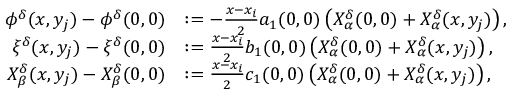<formula> <loc_0><loc_0><loc_500><loc_500>\begin{array} { r l } { \phi ^ { \delta } ( x , y _ { j } ) - \phi ^ { \delta } ( 0 , 0 ) } & { \colon = - \frac { x - x _ { i } } { 2 } a _ { 1 } ( 0 , 0 ) \left ( X _ { \alpha } ^ { \delta } ( 0 , 0 ) + X _ { \alpha } ^ { \delta } ( x , y _ { j } ) \right ) , } \\ { \xi ^ { \delta } ( x , y _ { j } ) - \xi ^ { \delta } ( 0 , 0 ) } & { \colon = \frac { x - x _ { i } } { 2 } b _ { 1 } ( 0 , 0 ) \left ( X _ { \alpha } ^ { \delta } ( 0 , 0 ) + X _ { \alpha } ^ { \delta } ( x , y _ { j } ) \right ) , } \\ { X _ { \beta } ^ { \delta } ( x , y _ { j } ) - X _ { \beta } ^ { \delta } ( 0 , 0 ) } & { \colon = \frac { x - x _ { i } } { 2 } c _ { 1 } ( 0 , 0 ) \left ( X _ { \alpha } ^ { \delta } ( 0 , 0 ) + X _ { \alpha } ^ { \delta } ( x , y _ { j } ) \right ) , } \end{array}</formula> 